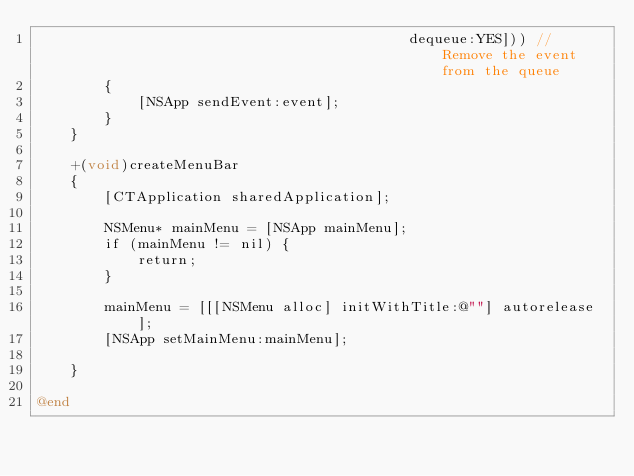<code> <loc_0><loc_0><loc_500><loc_500><_ObjectiveC_>											dequeue:YES])) // Remove the event from the queue
		{
			[NSApp sendEvent:event];
		}
	}

	+(void)createMenuBar
	{
		[CTApplication sharedApplication];

		NSMenu* mainMenu = [NSApp mainMenu];
		if (mainMenu != nil) {
			return;
		}

		mainMenu = [[[NSMenu alloc] initWithTitle:@""] autorelease];
		[NSApp setMainMenu:mainMenu];

	}

@end
</code> 